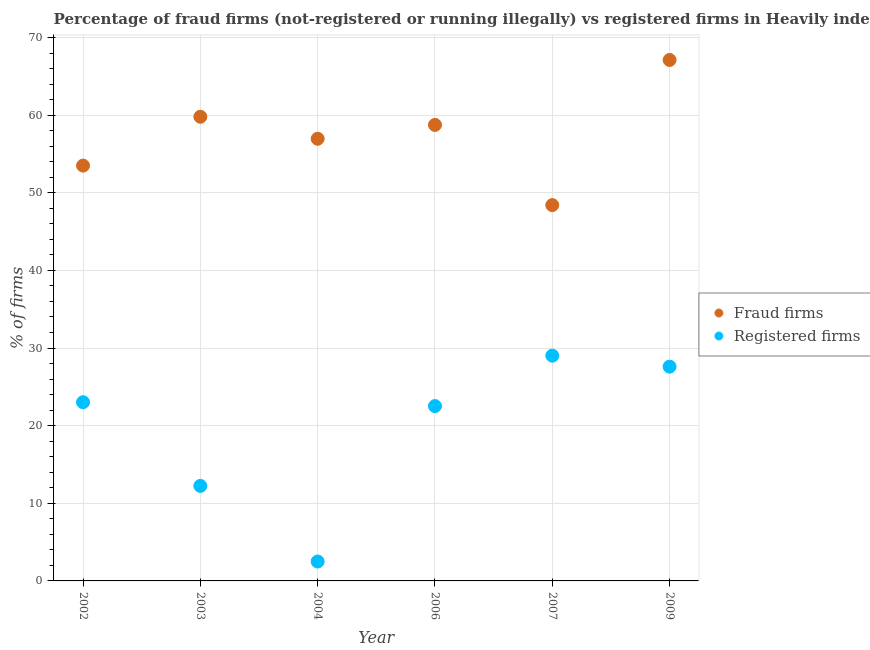What is the percentage of fraud firms in 2006?
Your answer should be very brief. 58.74. Across all years, what is the maximum percentage of fraud firms?
Your response must be concise. 67.11. Across all years, what is the minimum percentage of fraud firms?
Your answer should be compact. 48.41. In which year was the percentage of fraud firms maximum?
Give a very brief answer. 2009. In which year was the percentage of registered firms minimum?
Offer a very short reply. 2004. What is the total percentage of fraud firms in the graph?
Ensure brevity in your answer.  344.5. What is the difference between the percentage of fraud firms in 2002 and that in 2004?
Give a very brief answer. -3.45. What is the difference between the percentage of registered firms in 2004 and the percentage of fraud firms in 2009?
Offer a terse response. -64.61. What is the average percentage of fraud firms per year?
Provide a succinct answer. 57.42. In the year 2002, what is the difference between the percentage of registered firms and percentage of fraud firms?
Provide a short and direct response. -30.48. What is the ratio of the percentage of registered firms in 2003 to that in 2004?
Ensure brevity in your answer.  4.9. Is the difference between the percentage of fraud firms in 2003 and 2006 greater than the difference between the percentage of registered firms in 2003 and 2006?
Provide a succinct answer. Yes. What is the difference between the highest and the second highest percentage of registered firms?
Make the answer very short. 1.42. What is the difference between the highest and the lowest percentage of fraud firms?
Your answer should be compact. 18.7. In how many years, is the percentage of fraud firms greater than the average percentage of fraud firms taken over all years?
Your response must be concise. 3. Is the percentage of fraud firms strictly greater than the percentage of registered firms over the years?
Make the answer very short. Yes. Is the percentage of fraud firms strictly less than the percentage of registered firms over the years?
Your answer should be very brief. No. How many dotlines are there?
Give a very brief answer. 2. How many years are there in the graph?
Offer a very short reply. 6. Are the values on the major ticks of Y-axis written in scientific E-notation?
Your response must be concise. No. Does the graph contain any zero values?
Offer a terse response. No. Where does the legend appear in the graph?
Ensure brevity in your answer.  Center right. What is the title of the graph?
Provide a short and direct response. Percentage of fraud firms (not-registered or running illegally) vs registered firms in Heavily indebted poor countries. Does "Secondary Education" appear as one of the legend labels in the graph?
Your answer should be very brief. No. What is the label or title of the Y-axis?
Offer a very short reply. % of firms. What is the % of firms of Fraud firms in 2002?
Provide a succinct answer. 53.5. What is the % of firms of Registered firms in 2002?
Your answer should be compact. 23.02. What is the % of firms of Fraud firms in 2003?
Provide a succinct answer. 59.79. What is the % of firms of Registered firms in 2003?
Your response must be concise. 12.24. What is the % of firms in Fraud firms in 2004?
Offer a very short reply. 56.95. What is the % of firms in Registered firms in 2004?
Give a very brief answer. 2.5. What is the % of firms in Fraud firms in 2006?
Offer a very short reply. 58.74. What is the % of firms in Registered firms in 2006?
Your answer should be very brief. 22.52. What is the % of firms of Fraud firms in 2007?
Make the answer very short. 48.41. What is the % of firms of Registered firms in 2007?
Offer a terse response. 29.02. What is the % of firms in Fraud firms in 2009?
Make the answer very short. 67.11. What is the % of firms of Registered firms in 2009?
Keep it short and to the point. 27.6. Across all years, what is the maximum % of firms of Fraud firms?
Your response must be concise. 67.11. Across all years, what is the maximum % of firms in Registered firms?
Your answer should be compact. 29.02. Across all years, what is the minimum % of firms in Fraud firms?
Give a very brief answer. 48.41. Across all years, what is the minimum % of firms of Registered firms?
Ensure brevity in your answer.  2.5. What is the total % of firms in Fraud firms in the graph?
Provide a short and direct response. 344.5. What is the total % of firms in Registered firms in the graph?
Offer a very short reply. 116.9. What is the difference between the % of firms in Fraud firms in 2002 and that in 2003?
Offer a terse response. -6.29. What is the difference between the % of firms in Registered firms in 2002 and that in 2003?
Keep it short and to the point. 10.78. What is the difference between the % of firms of Fraud firms in 2002 and that in 2004?
Give a very brief answer. -3.46. What is the difference between the % of firms of Registered firms in 2002 and that in 2004?
Your answer should be compact. 20.52. What is the difference between the % of firms in Fraud firms in 2002 and that in 2006?
Provide a succinct answer. -5.24. What is the difference between the % of firms of Registered firms in 2002 and that in 2006?
Provide a succinct answer. 0.5. What is the difference between the % of firms in Fraud firms in 2002 and that in 2007?
Your answer should be very brief. 5.09. What is the difference between the % of firms of Registered firms in 2002 and that in 2007?
Your answer should be very brief. -6. What is the difference between the % of firms in Fraud firms in 2002 and that in 2009?
Ensure brevity in your answer.  -13.61. What is the difference between the % of firms of Registered firms in 2002 and that in 2009?
Make the answer very short. -4.58. What is the difference between the % of firms in Fraud firms in 2003 and that in 2004?
Offer a very short reply. 2.83. What is the difference between the % of firms in Registered firms in 2003 and that in 2004?
Give a very brief answer. 9.74. What is the difference between the % of firms in Fraud firms in 2003 and that in 2006?
Offer a terse response. 1.05. What is the difference between the % of firms in Registered firms in 2003 and that in 2006?
Your response must be concise. -10.28. What is the difference between the % of firms in Fraud firms in 2003 and that in 2007?
Make the answer very short. 11.38. What is the difference between the % of firms of Registered firms in 2003 and that in 2007?
Your response must be concise. -16.78. What is the difference between the % of firms of Fraud firms in 2003 and that in 2009?
Your answer should be very brief. -7.32. What is the difference between the % of firms in Registered firms in 2003 and that in 2009?
Provide a succinct answer. -15.36. What is the difference between the % of firms of Fraud firms in 2004 and that in 2006?
Offer a very short reply. -1.79. What is the difference between the % of firms in Registered firms in 2004 and that in 2006?
Your response must be concise. -20.02. What is the difference between the % of firms in Fraud firms in 2004 and that in 2007?
Offer a very short reply. 8.54. What is the difference between the % of firms in Registered firms in 2004 and that in 2007?
Offer a very short reply. -26.52. What is the difference between the % of firms in Fraud firms in 2004 and that in 2009?
Offer a very short reply. -10.15. What is the difference between the % of firms of Registered firms in 2004 and that in 2009?
Ensure brevity in your answer.  -25.1. What is the difference between the % of firms in Fraud firms in 2006 and that in 2007?
Your response must be concise. 10.33. What is the difference between the % of firms in Registered firms in 2006 and that in 2007?
Provide a short and direct response. -6.49. What is the difference between the % of firms in Fraud firms in 2006 and that in 2009?
Your response must be concise. -8.37. What is the difference between the % of firms in Registered firms in 2006 and that in 2009?
Give a very brief answer. -5.08. What is the difference between the % of firms in Fraud firms in 2007 and that in 2009?
Keep it short and to the point. -18.7. What is the difference between the % of firms of Registered firms in 2007 and that in 2009?
Offer a very short reply. 1.42. What is the difference between the % of firms of Fraud firms in 2002 and the % of firms of Registered firms in 2003?
Keep it short and to the point. 41.26. What is the difference between the % of firms of Fraud firms in 2002 and the % of firms of Registered firms in 2004?
Your answer should be very brief. 51. What is the difference between the % of firms of Fraud firms in 2002 and the % of firms of Registered firms in 2006?
Make the answer very short. 30.98. What is the difference between the % of firms of Fraud firms in 2002 and the % of firms of Registered firms in 2007?
Make the answer very short. 24.48. What is the difference between the % of firms of Fraud firms in 2002 and the % of firms of Registered firms in 2009?
Make the answer very short. 25.9. What is the difference between the % of firms in Fraud firms in 2003 and the % of firms in Registered firms in 2004?
Offer a terse response. 57.29. What is the difference between the % of firms in Fraud firms in 2003 and the % of firms in Registered firms in 2006?
Offer a terse response. 37.27. What is the difference between the % of firms of Fraud firms in 2003 and the % of firms of Registered firms in 2007?
Provide a short and direct response. 30.77. What is the difference between the % of firms of Fraud firms in 2003 and the % of firms of Registered firms in 2009?
Your answer should be very brief. 32.19. What is the difference between the % of firms in Fraud firms in 2004 and the % of firms in Registered firms in 2006?
Provide a short and direct response. 34.43. What is the difference between the % of firms in Fraud firms in 2004 and the % of firms in Registered firms in 2007?
Your answer should be very brief. 27.94. What is the difference between the % of firms in Fraud firms in 2004 and the % of firms in Registered firms in 2009?
Offer a terse response. 29.36. What is the difference between the % of firms of Fraud firms in 2006 and the % of firms of Registered firms in 2007?
Keep it short and to the point. 29.72. What is the difference between the % of firms in Fraud firms in 2006 and the % of firms in Registered firms in 2009?
Make the answer very short. 31.14. What is the difference between the % of firms in Fraud firms in 2007 and the % of firms in Registered firms in 2009?
Keep it short and to the point. 20.81. What is the average % of firms in Fraud firms per year?
Offer a very short reply. 57.42. What is the average % of firms in Registered firms per year?
Make the answer very short. 19.48. In the year 2002, what is the difference between the % of firms in Fraud firms and % of firms in Registered firms?
Offer a terse response. 30.48. In the year 2003, what is the difference between the % of firms of Fraud firms and % of firms of Registered firms?
Your answer should be compact. 47.55. In the year 2004, what is the difference between the % of firms of Fraud firms and % of firms of Registered firms?
Keep it short and to the point. 54.45. In the year 2006, what is the difference between the % of firms of Fraud firms and % of firms of Registered firms?
Ensure brevity in your answer.  36.22. In the year 2007, what is the difference between the % of firms in Fraud firms and % of firms in Registered firms?
Offer a terse response. 19.39. In the year 2009, what is the difference between the % of firms of Fraud firms and % of firms of Registered firms?
Your answer should be compact. 39.51. What is the ratio of the % of firms in Fraud firms in 2002 to that in 2003?
Keep it short and to the point. 0.89. What is the ratio of the % of firms of Registered firms in 2002 to that in 2003?
Make the answer very short. 1.88. What is the ratio of the % of firms in Fraud firms in 2002 to that in 2004?
Keep it short and to the point. 0.94. What is the ratio of the % of firms in Registered firms in 2002 to that in 2004?
Keep it short and to the point. 9.21. What is the ratio of the % of firms of Fraud firms in 2002 to that in 2006?
Provide a short and direct response. 0.91. What is the ratio of the % of firms of Registered firms in 2002 to that in 2006?
Provide a short and direct response. 1.02. What is the ratio of the % of firms in Fraud firms in 2002 to that in 2007?
Provide a short and direct response. 1.11. What is the ratio of the % of firms in Registered firms in 2002 to that in 2007?
Your answer should be very brief. 0.79. What is the ratio of the % of firms in Fraud firms in 2002 to that in 2009?
Your answer should be very brief. 0.8. What is the ratio of the % of firms in Registered firms in 2002 to that in 2009?
Offer a very short reply. 0.83. What is the ratio of the % of firms in Fraud firms in 2003 to that in 2004?
Provide a short and direct response. 1.05. What is the ratio of the % of firms in Registered firms in 2003 to that in 2004?
Offer a very short reply. 4.9. What is the ratio of the % of firms in Fraud firms in 2003 to that in 2006?
Offer a very short reply. 1.02. What is the ratio of the % of firms in Registered firms in 2003 to that in 2006?
Your answer should be compact. 0.54. What is the ratio of the % of firms in Fraud firms in 2003 to that in 2007?
Offer a very short reply. 1.24. What is the ratio of the % of firms of Registered firms in 2003 to that in 2007?
Provide a succinct answer. 0.42. What is the ratio of the % of firms in Fraud firms in 2003 to that in 2009?
Ensure brevity in your answer.  0.89. What is the ratio of the % of firms of Registered firms in 2003 to that in 2009?
Provide a succinct answer. 0.44. What is the ratio of the % of firms in Fraud firms in 2004 to that in 2006?
Offer a very short reply. 0.97. What is the ratio of the % of firms of Registered firms in 2004 to that in 2006?
Make the answer very short. 0.11. What is the ratio of the % of firms in Fraud firms in 2004 to that in 2007?
Give a very brief answer. 1.18. What is the ratio of the % of firms of Registered firms in 2004 to that in 2007?
Ensure brevity in your answer.  0.09. What is the ratio of the % of firms in Fraud firms in 2004 to that in 2009?
Make the answer very short. 0.85. What is the ratio of the % of firms of Registered firms in 2004 to that in 2009?
Provide a succinct answer. 0.09. What is the ratio of the % of firms in Fraud firms in 2006 to that in 2007?
Give a very brief answer. 1.21. What is the ratio of the % of firms in Registered firms in 2006 to that in 2007?
Give a very brief answer. 0.78. What is the ratio of the % of firms of Fraud firms in 2006 to that in 2009?
Make the answer very short. 0.88. What is the ratio of the % of firms of Registered firms in 2006 to that in 2009?
Offer a terse response. 0.82. What is the ratio of the % of firms of Fraud firms in 2007 to that in 2009?
Provide a short and direct response. 0.72. What is the ratio of the % of firms in Registered firms in 2007 to that in 2009?
Your response must be concise. 1.05. What is the difference between the highest and the second highest % of firms in Fraud firms?
Your answer should be very brief. 7.32. What is the difference between the highest and the second highest % of firms of Registered firms?
Make the answer very short. 1.42. What is the difference between the highest and the lowest % of firms in Fraud firms?
Give a very brief answer. 18.7. What is the difference between the highest and the lowest % of firms of Registered firms?
Ensure brevity in your answer.  26.52. 